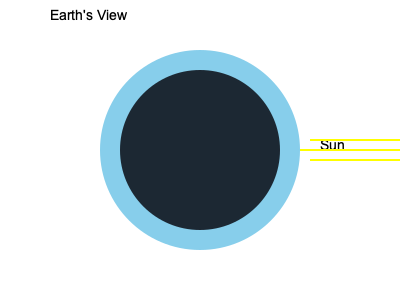As a software engineer working on a Flex-based astronomical visualization tool, you need to accurately represent the moon phases. Given the diagram showing the moon's appearance from Earth, which phase of the moon is depicted, and what is the approximate percentage of the illuminated surface visible from Earth? To determine the moon phase and visible illumination:

1. Analyze the diagram:
   - The circle represents the moon as seen from Earth.
   - The dark portion is the unlit side, and the light portion is illuminated by the Sun.

2. Identify the phase:
   - The right half of the moon is illuminated.
   - This configuration corresponds to the First Quarter phase.

3. Calculate the visible illumination:
   - In the First Quarter phase, exactly half of the moon's Earth-facing side is illuminated.
   - The illuminated portion represents 50% of the visible surface.

4. Relate to Flex development:
   - When programming the visualization, you'd use ActionScript to draw the moon shape and apply appropriate shading.
   - The illumination percentage would be a variable used to control the rendering of the moon's appearance.

5. Importance in astronomical tools:
   - Accurate representation of moon phases is crucial for educational and scientific applications.
   - The First Quarter phase is a key reference point in the lunar cycle.
Answer: First Quarter, 50% illuminated 